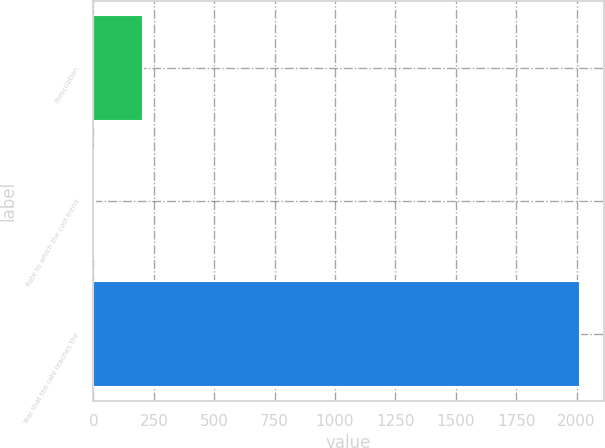<chart> <loc_0><loc_0><loc_500><loc_500><bar_chart><fcel>Prescription<fcel>Rate to which the cost trend<fcel>Year that the rate reaches the<nl><fcel>205.7<fcel>5<fcel>2012<nl></chart> 